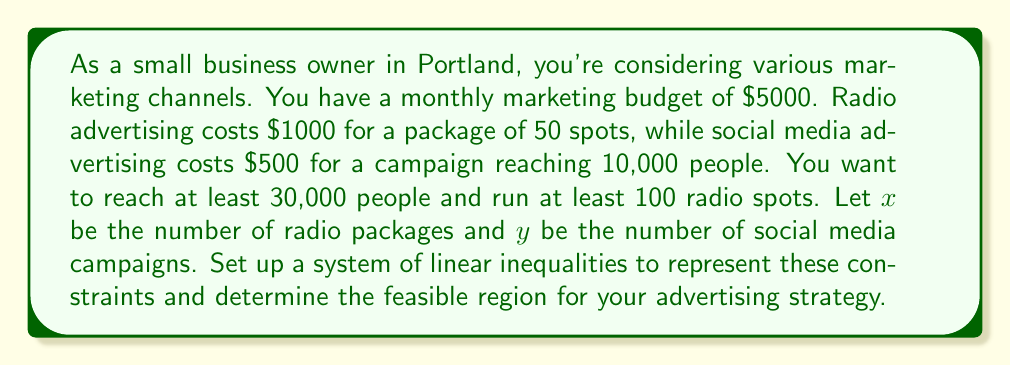Show me your answer to this math problem. Let's break down the problem and set up the inequalities:

1. Budget constraint:
   Each radio package costs $1000 and each social media campaign costs $500.
   The total cost must not exceed $5000.
   $$1000x + 500y \leq 5000$$

2. Minimum radio spots:
   Each radio package contains 50 spots, and you want at least 100 spots.
   $$50x \geq 100$$
   Simplifying: $$x \geq 2$$

3. Minimum reach:
   Each radio package reaches an unspecified number of people, so we'll focus on the social media reach.
   Each social media campaign reaches 10,000 people, and you want to reach at least 30,000 people.
   $$10000y \geq 30000$$
   Simplifying: $$y \geq 3$$

4. Non-negativity constraints:
   $$x \geq 0$$
   $$y \geq 0$$

The feasible region is the area that satisfies all these inequalities simultaneously. To visualize this, we can graph the inequalities:

[asy]
import graph;
size(200);
xaxis("x (Radio packages)", 0, 6, Arrow);
yaxis("y (Social media campaigns)", 0, 12, Arrow);

draw((0,10)--(5,0), blue);
draw((2,0)--(2,12), red);
draw((0,3)--(6,3), green);

fill((2,3)--(2,8)--(3,6)--(5,3)--(2,3), lightgray);

label("Budget constraint", (2.5,7), W, blue);
label("Min. radio spots", (2,6), E, red);
label("Min. reach", (4,3), N, green);

dot((2,3));
dot((2,8));
dot((3,6));
dot((5,3));

label("(2,3)", (2,3), SW);
label("(2,8)", (2,8), NE);
label("(3,6)", (3,6), NE);
label("(5,3)", (5,3), SE);
[/asy]

The shaded region represents the feasible solutions that satisfy all constraints.
Answer: The system of linear inequalities representing the constraints is:

$$\begin{cases}
1000x + 500y \leq 5000 \\
x \geq 2 \\
y \geq 3 \\
x \geq 0 \\
y \geq 0
\end{cases}$$

The feasible region is the quadrilateral bounded by the points (2,3), (2,8), (3,6), and (5,3). 